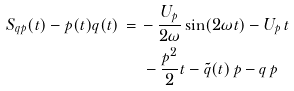<formula> <loc_0><loc_0><loc_500><loc_500>S _ { q p } ( t ) - p ( t ) q ( t ) \, = \, & - \frac { U _ { p } } { 2 \omega } \sin ( 2 \omega t ) - U _ { p } \, t \\ & \, - \frac { p ^ { 2 } } { 2 } t - \tilde { q } ( t ) \, p - q \, p</formula> 